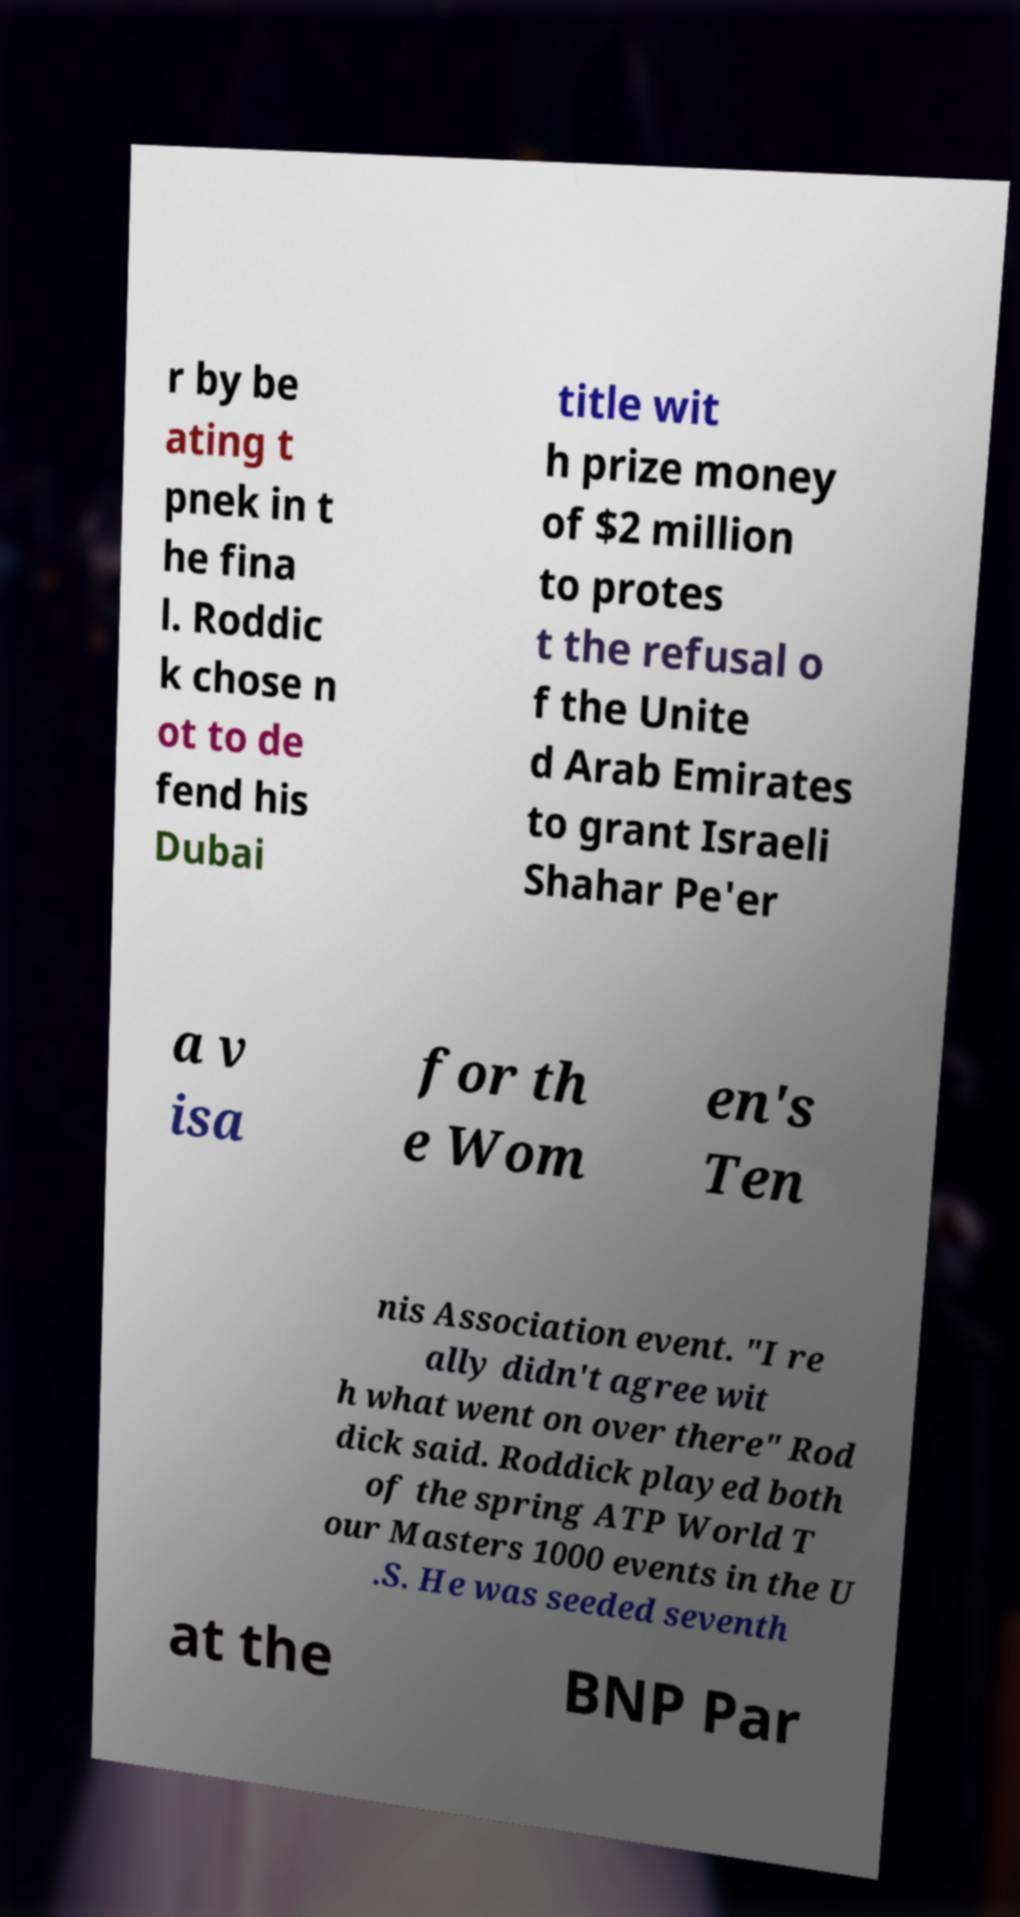Please read and relay the text visible in this image. What does it say? r by be ating t pnek in t he fina l. Roddic k chose n ot to de fend his Dubai title wit h prize money of $2 million to protes t the refusal o f the Unite d Arab Emirates to grant Israeli Shahar Pe'er a v isa for th e Wom en's Ten nis Association event. "I re ally didn't agree wit h what went on over there" Rod dick said. Roddick played both of the spring ATP World T our Masters 1000 events in the U .S. He was seeded seventh at the BNP Par 